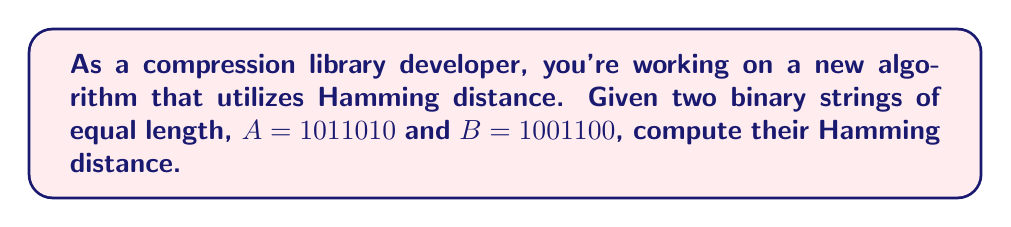Show me your answer to this math problem. To compute the Hamming distance between two binary strings, we need to follow these steps:

1. Ensure both strings are of equal length (which they are in this case).

2. Compare the strings bit by bit, counting the number of positions where the bits differ.

3. The total count of differing bits is the Hamming distance.

Let's compare $A$ and $B$:

$A = 1011010$
$B = 1001100$

Comparing each bit:

1. First bit:  $1 = 1$ (same)
2. Second bit: $0 = 0$ (same)
3. Third bit:  $1 \neq 0$ (different, count = 1)
4. Fourth bit: $1 \neq 1$ (same)
5. Fifth bit:  $0 = 0$ (same)
6. Sixth bit:  $1 \neq 0$ (different, count = 2)
7. Seventh bit: $0 = 0$ (same)

The Hamming distance is the total count of differences, which is 2.

In terms of compression, this Hamming distance indicates that these two strings differ in 2 out of 7 bits, which could be useful for various compression techniques or error detection algorithms.
Answer: 2 